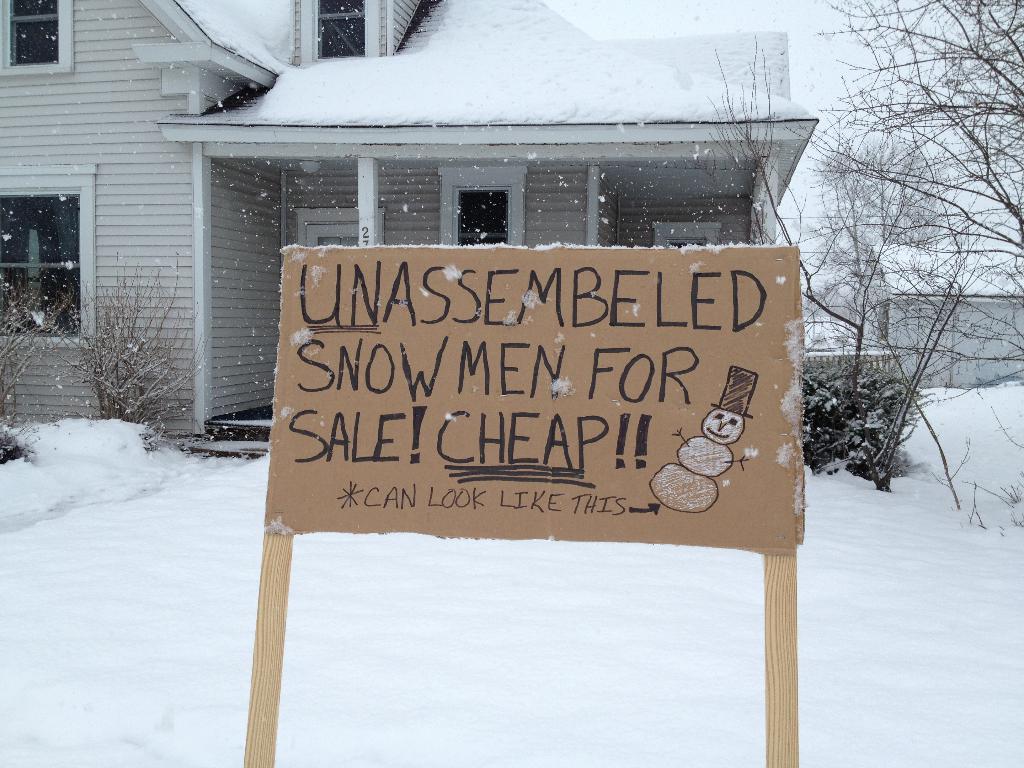How would you summarize this image in a sentence or two? In this picture I can see the building, trees, plants and snow. In the center I can see the board and something is written on it. In the background I can see the wall partition. At the top I can see the sky and now. 